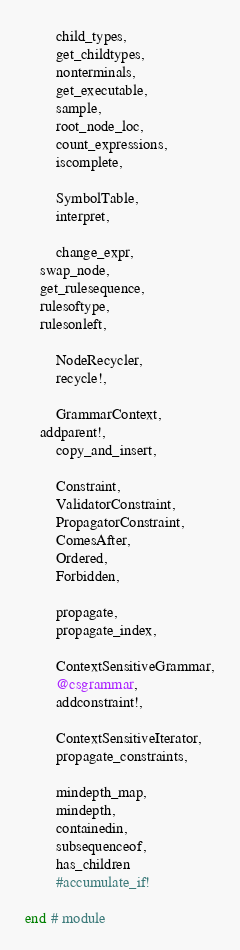<code> <loc_0><loc_0><loc_500><loc_500><_Julia_>        child_types,
        get_childtypes,
        nonterminals,
        get_executable,
        sample,
        root_node_loc,
        count_expressions,
        iscomplete,

        SymbolTable,
        interpret,

        change_expr,
	swap_node,
	get_rulesequence,
	rulesoftype,
	rulesonleft,

        NodeRecycler,
        recycle!,

        GrammarContext,
	addparent!,
        copy_and_insert,

        Constraint,
        ValidatorConstraint,
        PropagatorConstraint,
        ComesAfter,
        Ordered,
        Forbidden,

        propagate,
        propagate_index,

        ContextSensitiveGrammar,
        @csgrammar,
        addconstraint!,

        ContextSensitiveIterator,
        propagate_constraints,

        mindepth_map,
        mindepth,
        containedin,
        subsequenceof,
        has_children
        #accumulate_if!

end # module
</code> 